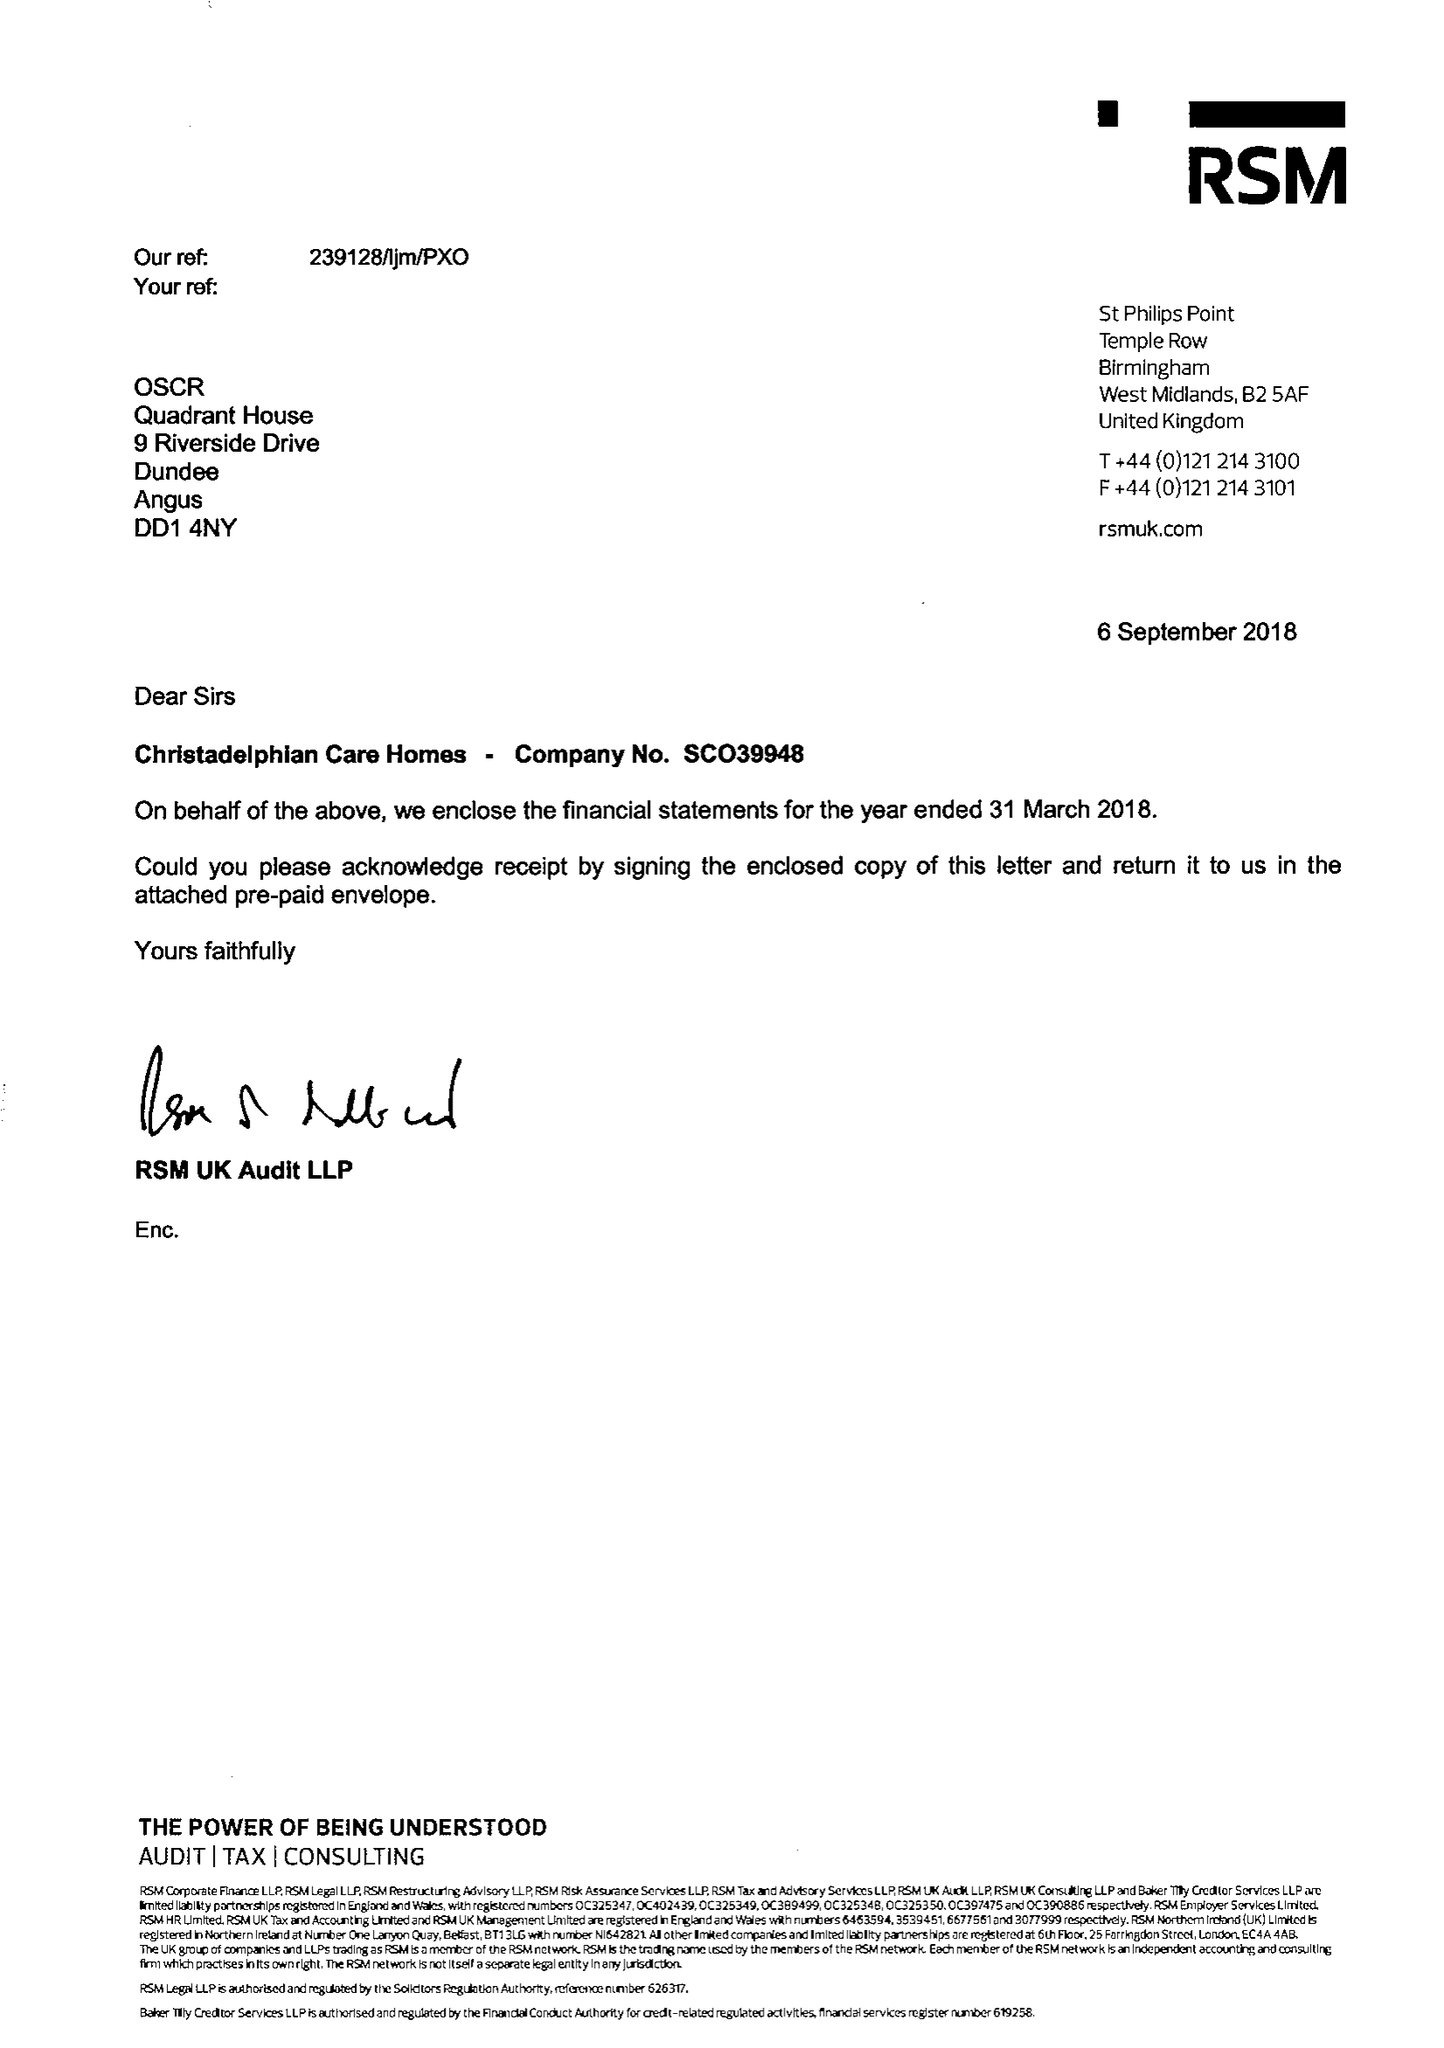What is the value for the address__street_line?
Answer the question using a single word or phrase. 17 SHERBOURNE ROAD 